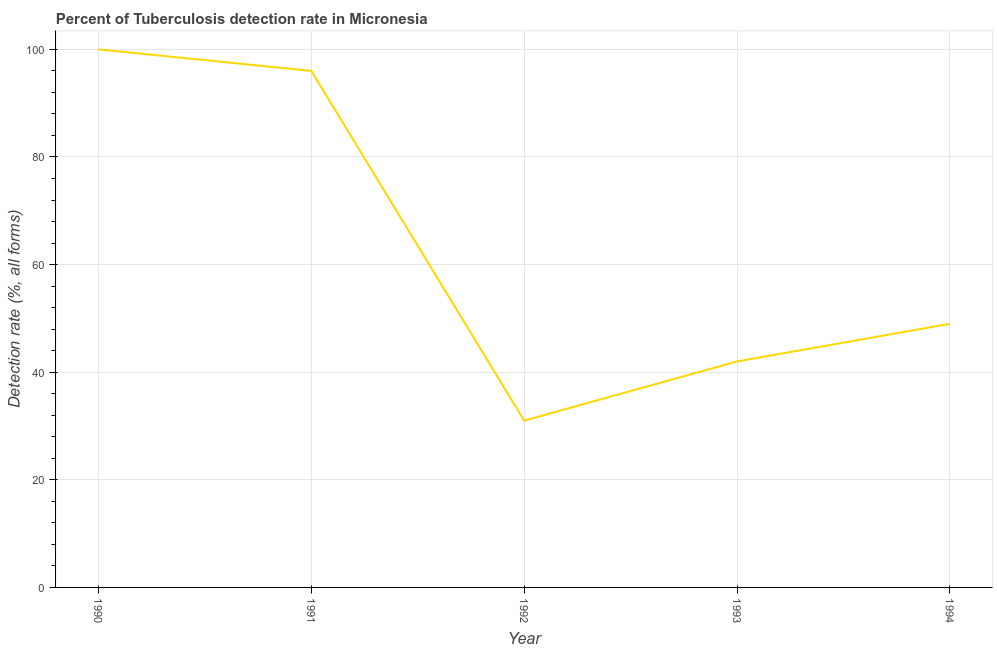What is the detection rate of tuberculosis in 1990?
Provide a succinct answer. 100. Across all years, what is the maximum detection rate of tuberculosis?
Your response must be concise. 100. Across all years, what is the minimum detection rate of tuberculosis?
Your answer should be very brief. 31. What is the sum of the detection rate of tuberculosis?
Your response must be concise. 318. What is the difference between the detection rate of tuberculosis in 1991 and 1994?
Provide a succinct answer. 47. What is the average detection rate of tuberculosis per year?
Provide a short and direct response. 63.6. What is the median detection rate of tuberculosis?
Provide a short and direct response. 49. In how many years, is the detection rate of tuberculosis greater than 60 %?
Make the answer very short. 2. Do a majority of the years between 1991 and 1992 (inclusive) have detection rate of tuberculosis greater than 20 %?
Keep it short and to the point. Yes. What is the ratio of the detection rate of tuberculosis in 1992 to that in 1994?
Provide a succinct answer. 0.63. Is the sum of the detection rate of tuberculosis in 1991 and 1992 greater than the maximum detection rate of tuberculosis across all years?
Keep it short and to the point. Yes. What is the difference between the highest and the lowest detection rate of tuberculosis?
Provide a short and direct response. 69. How many lines are there?
Keep it short and to the point. 1. What is the difference between two consecutive major ticks on the Y-axis?
Your answer should be compact. 20. Does the graph contain grids?
Provide a succinct answer. Yes. What is the title of the graph?
Keep it short and to the point. Percent of Tuberculosis detection rate in Micronesia. What is the label or title of the Y-axis?
Keep it short and to the point. Detection rate (%, all forms). What is the Detection rate (%, all forms) in 1991?
Provide a short and direct response. 96. What is the Detection rate (%, all forms) of 1993?
Your answer should be very brief. 42. What is the Detection rate (%, all forms) of 1994?
Offer a very short reply. 49. What is the difference between the Detection rate (%, all forms) in 1990 and 1991?
Provide a succinct answer. 4. What is the difference between the Detection rate (%, all forms) in 1990 and 1992?
Provide a succinct answer. 69. What is the difference between the Detection rate (%, all forms) in 1990 and 1993?
Give a very brief answer. 58. What is the difference between the Detection rate (%, all forms) in 1990 and 1994?
Your answer should be very brief. 51. What is the difference between the Detection rate (%, all forms) in 1991 and 1993?
Ensure brevity in your answer.  54. What is the difference between the Detection rate (%, all forms) in 1991 and 1994?
Offer a very short reply. 47. What is the difference between the Detection rate (%, all forms) in 1992 and 1993?
Provide a succinct answer. -11. What is the ratio of the Detection rate (%, all forms) in 1990 to that in 1991?
Keep it short and to the point. 1.04. What is the ratio of the Detection rate (%, all forms) in 1990 to that in 1992?
Your answer should be compact. 3.23. What is the ratio of the Detection rate (%, all forms) in 1990 to that in 1993?
Make the answer very short. 2.38. What is the ratio of the Detection rate (%, all forms) in 1990 to that in 1994?
Make the answer very short. 2.04. What is the ratio of the Detection rate (%, all forms) in 1991 to that in 1992?
Your answer should be very brief. 3.1. What is the ratio of the Detection rate (%, all forms) in 1991 to that in 1993?
Offer a terse response. 2.29. What is the ratio of the Detection rate (%, all forms) in 1991 to that in 1994?
Make the answer very short. 1.96. What is the ratio of the Detection rate (%, all forms) in 1992 to that in 1993?
Give a very brief answer. 0.74. What is the ratio of the Detection rate (%, all forms) in 1992 to that in 1994?
Ensure brevity in your answer.  0.63. What is the ratio of the Detection rate (%, all forms) in 1993 to that in 1994?
Provide a succinct answer. 0.86. 